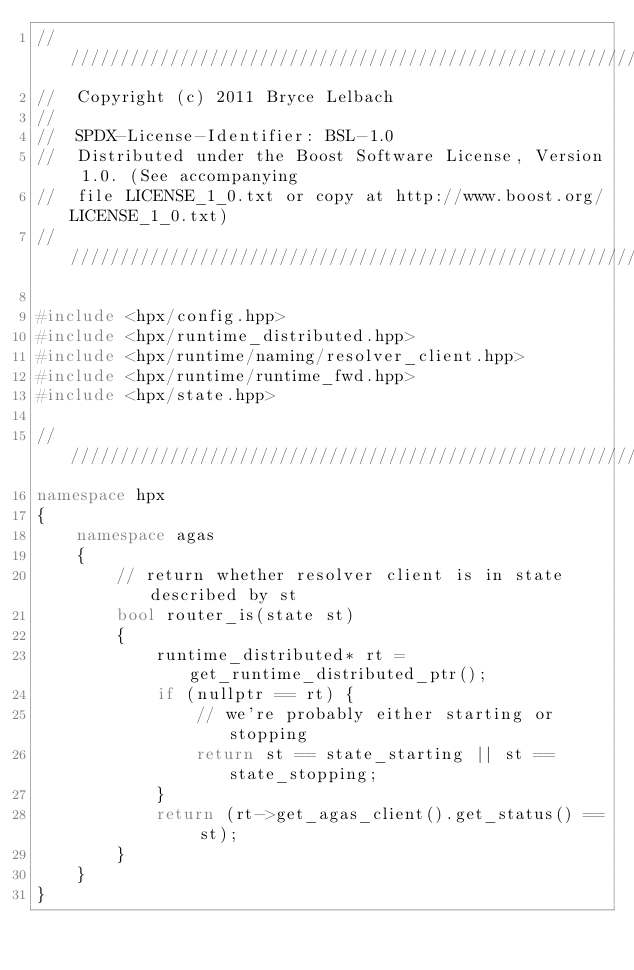Convert code to text. <code><loc_0><loc_0><loc_500><loc_500><_C++_>////////////////////////////////////////////////////////////////////////////////
//  Copyright (c) 2011 Bryce Lelbach
//
//  SPDX-License-Identifier: BSL-1.0
//  Distributed under the Boost Software License, Version 1.0. (See accompanying
//  file LICENSE_1_0.txt or copy at http://www.boost.org/LICENSE_1_0.txt)
////////////////////////////////////////////////////////////////////////////////

#include <hpx/config.hpp>
#include <hpx/runtime_distributed.hpp>
#include <hpx/runtime/naming/resolver_client.hpp>
#include <hpx/runtime/runtime_fwd.hpp>
#include <hpx/state.hpp>

///////////////////////////////////////////////////////////////////////////////
namespace hpx
{
    namespace agas
    {
        // return whether resolver client is in state described by st
        bool router_is(state st)
        {
            runtime_distributed* rt = get_runtime_distributed_ptr();
            if (nullptr == rt) {
                // we're probably either starting or stopping
                return st == state_starting || st == state_stopping;
            }
            return (rt->get_agas_client().get_status() == st);
        }
    }
}
</code> 